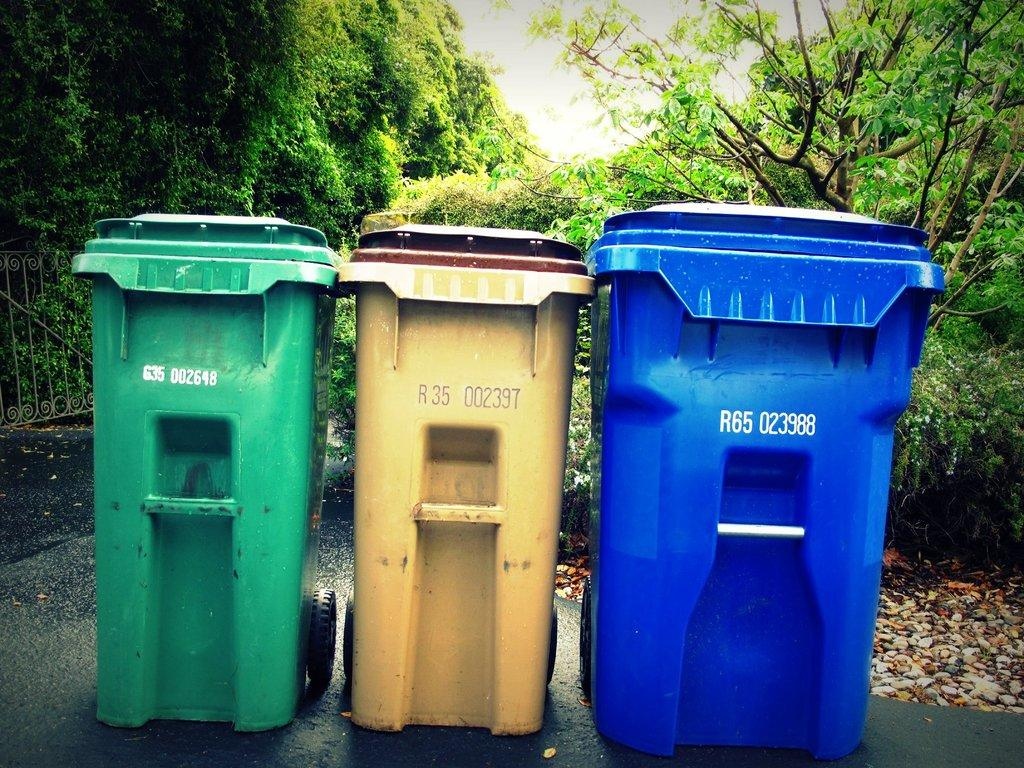<image>
Offer a succinct explanation of the picture presented. A row of garbage bins, the blue one reads R65 023988. 